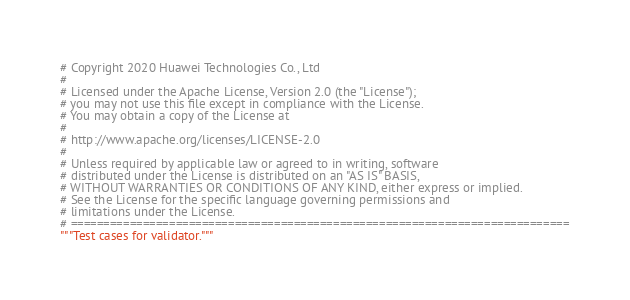Convert code to text. <code><loc_0><loc_0><loc_500><loc_500><_Python_># Copyright 2020 Huawei Technologies Co., Ltd
#
# Licensed under the Apache License, Version 2.0 (the "License");
# you may not use this file except in compliance with the License.
# You may obtain a copy of the License at
#
# http://www.apache.org/licenses/LICENSE-2.0
#
# Unless required by applicable law or agreed to in writing, software
# distributed under the License is distributed on an "AS IS" BASIS,
# WITHOUT WARRANTIES OR CONDITIONS OF ANY KIND, either express or implied.
# See the License for the specific language governing permissions and
# limitations under the License.
# ============================================================================
"""Test cases for validator."""
</code> 